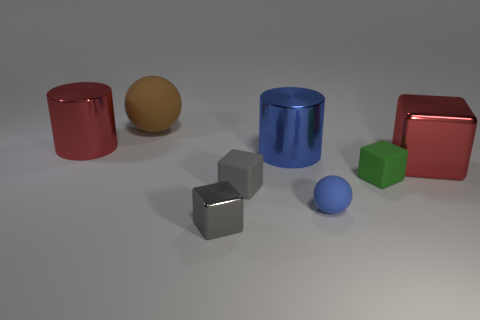There is a large thing in front of the metal cylinder that is in front of the big shiny cylinder on the left side of the big sphere; what is its color?
Your response must be concise. Red. What material is the big object that is the same shape as the small metal object?
Your answer should be compact. Metal. What is the color of the big matte sphere?
Your answer should be compact. Brown. Is the color of the big block the same as the big rubber ball?
Provide a short and direct response. No. What number of shiny things are either cyan cylinders or tiny balls?
Offer a terse response. 0. There is a metal cylinder behind the metal cylinder that is to the right of the big ball; are there any small blue matte spheres that are behind it?
Make the answer very short. No. What size is the gray thing that is the same material as the blue ball?
Provide a succinct answer. Small. Are there any gray matte objects to the right of the small green matte cube?
Ensure brevity in your answer.  No. Are there any red metal blocks that are to the right of the large blue metallic object in front of the large red cylinder?
Offer a very short reply. Yes. Do the metal cube on the left side of the blue sphere and the red metal thing that is on the left side of the brown matte ball have the same size?
Ensure brevity in your answer.  No. 